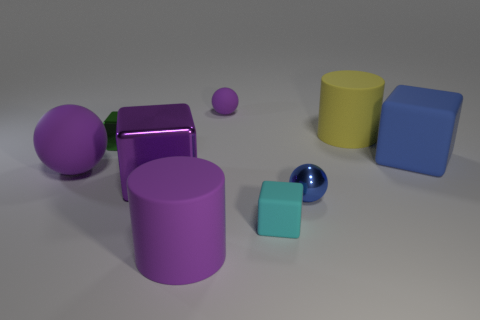There is a tiny thing that is to the left of the large purple shiny thing; does it have the same color as the large sphere? No, the smaller object to the left of the large purple shiny object is not the same color as the large sphere. The smaller object appears to be purple as well, but it is of a lighter shade compared to the deep purple hue of the large sphere. 